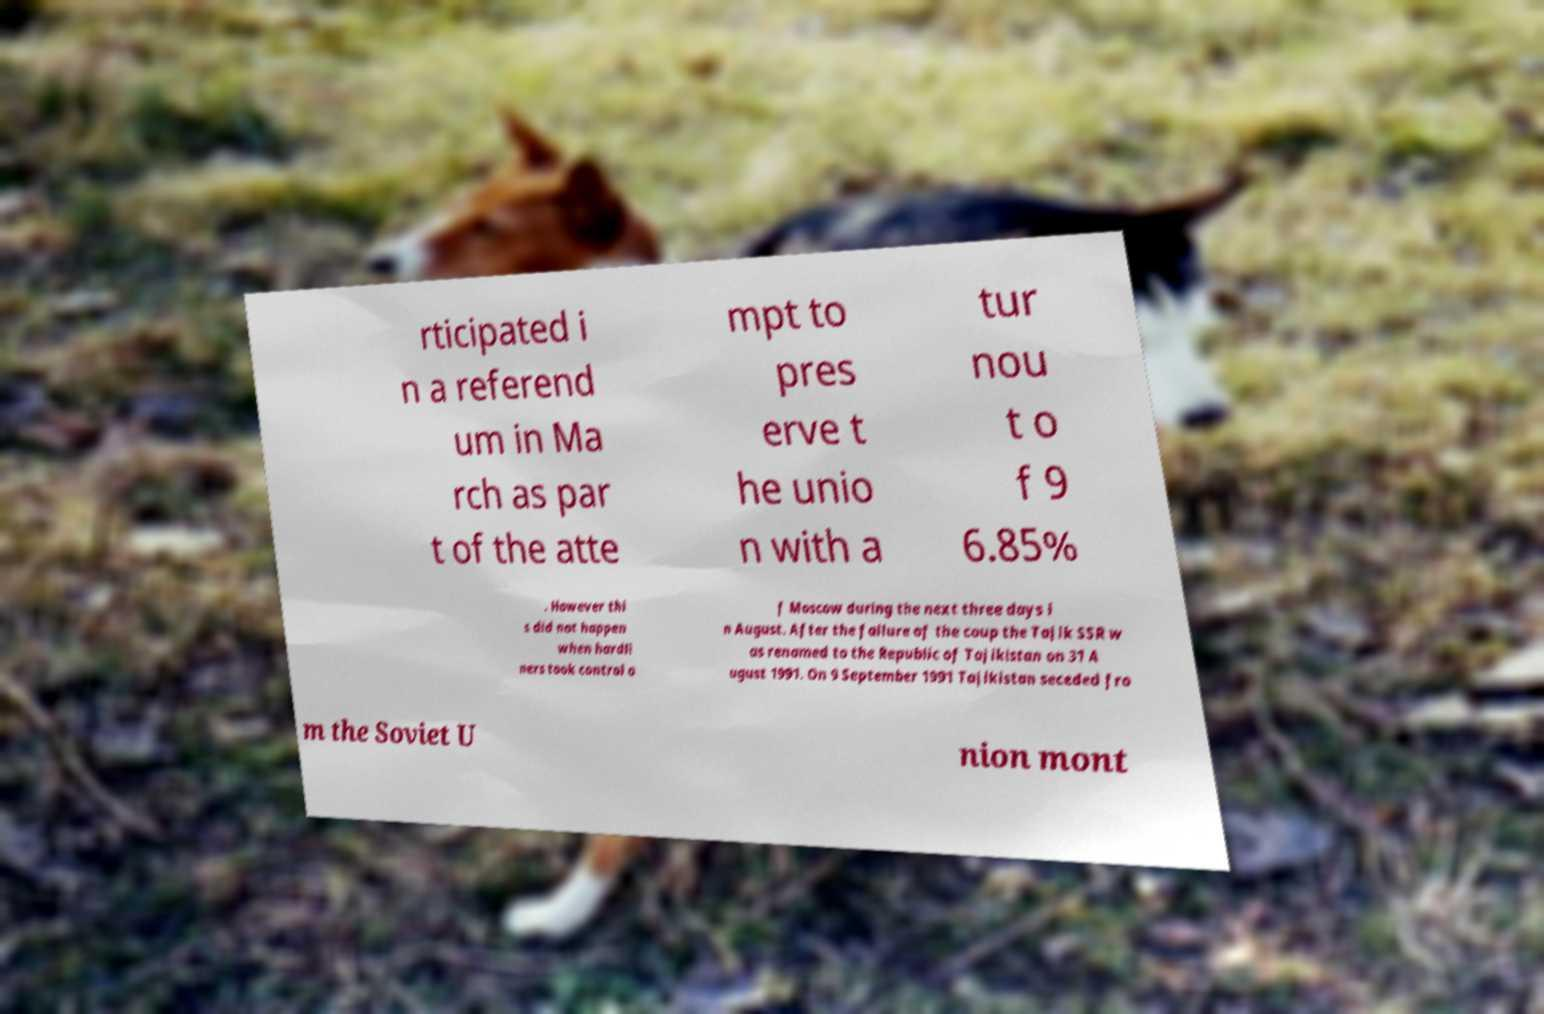Could you assist in decoding the text presented in this image and type it out clearly? rticipated i n a referend um in Ma rch as par t of the atte mpt to pres erve t he unio n with a tur nou t o f 9 6.85% . However thi s did not happen when hardli ners took control o f Moscow during the next three days i n August. After the failure of the coup the Tajik SSR w as renamed to the Republic of Tajikistan on 31 A ugust 1991. On 9 September 1991 Tajikistan seceded fro m the Soviet U nion mont 